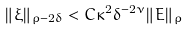Convert formula to latex. <formula><loc_0><loc_0><loc_500><loc_500>\| \xi \| _ { \rho - 2 \delta } < C \kappa ^ { 2 } \delta ^ { - 2 \nu } \| E \| _ { \rho }</formula> 